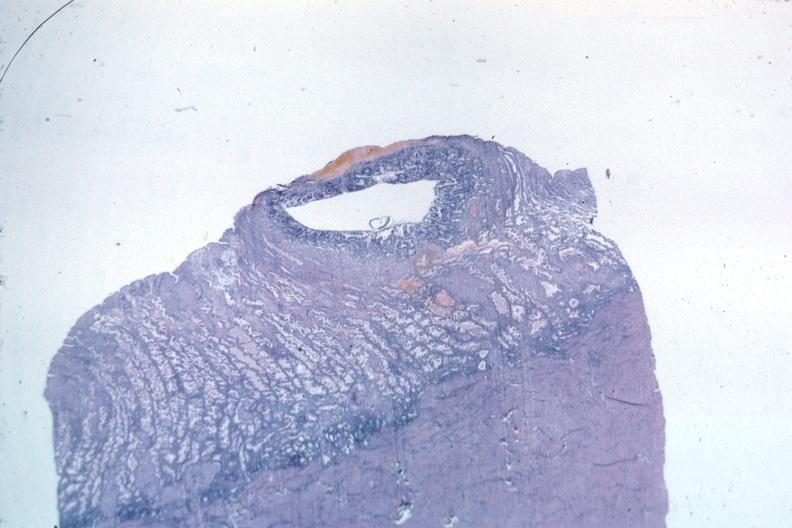s benign cystic teratoma present?
Answer the question using a single word or phrase. No 